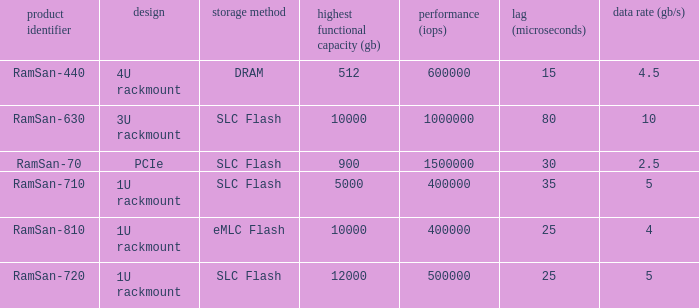What is the Input/output operations per second for the emlc flash? 400000.0. 